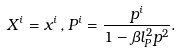<formula> <loc_0><loc_0><loc_500><loc_500>X ^ { i } = x ^ { i } \, , P ^ { i } = \frac { p ^ { i } } { 1 - \beta l _ { P } ^ { 2 } p ^ { 2 } } .</formula> 